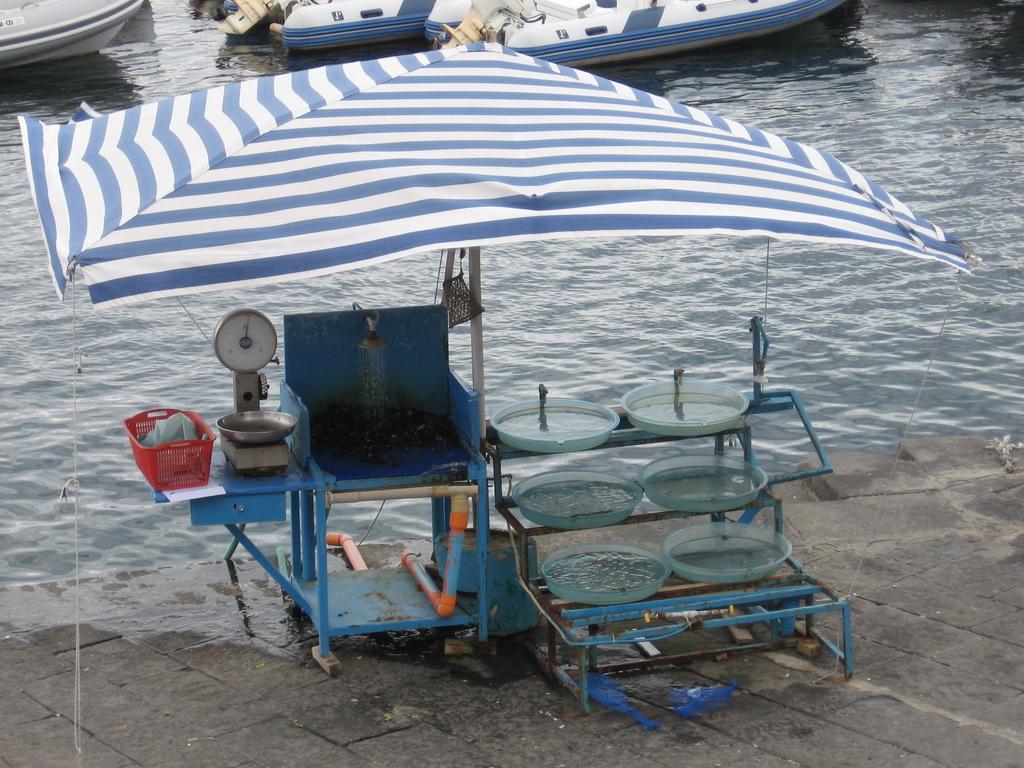Describe this image in one or two sentences. In the foreground of the pictures there are chair, plates, umbrella weighing machine, basket and other objects. In the center of the picture there are boats in the water. 